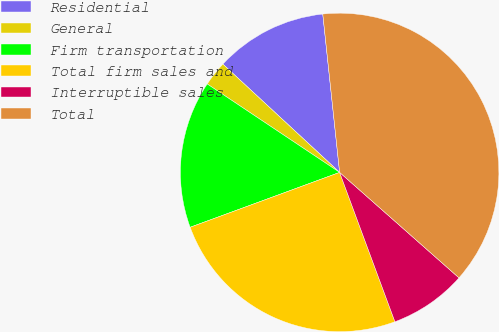Convert chart. <chart><loc_0><loc_0><loc_500><loc_500><pie_chart><fcel>Residential<fcel>General<fcel>Firm transportation<fcel>Total firm sales and<fcel>Interruptible sales<fcel>Total<nl><fcel>11.41%<fcel>2.53%<fcel>14.97%<fcel>25.04%<fcel>7.84%<fcel>38.2%<nl></chart> 